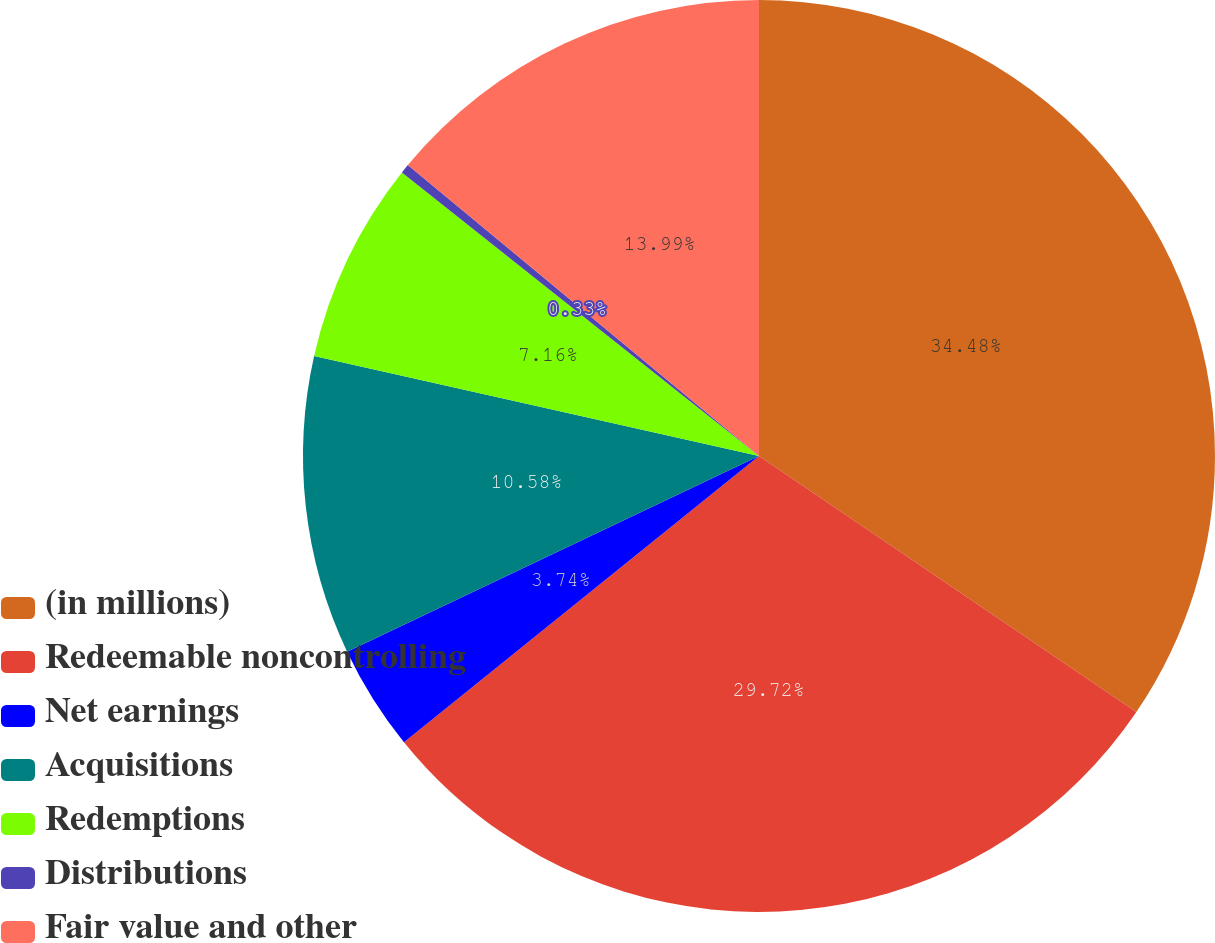Convert chart. <chart><loc_0><loc_0><loc_500><loc_500><pie_chart><fcel>(in millions)<fcel>Redeemable noncontrolling<fcel>Net earnings<fcel>Acquisitions<fcel>Redemptions<fcel>Distributions<fcel>Fair value and other<nl><fcel>34.49%<fcel>29.72%<fcel>3.74%<fcel>10.58%<fcel>7.16%<fcel>0.33%<fcel>13.99%<nl></chart> 